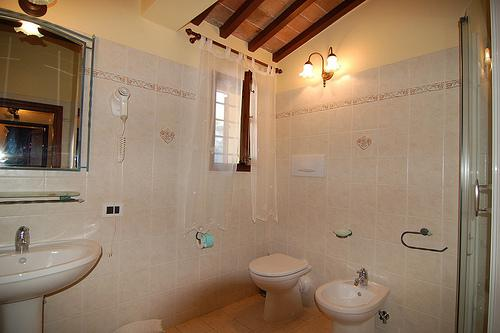Question: how is water obtained from sink?
Choices:
A. Cups.
B. Faucets.
C. Glasses.
D. Bottles.
Answer with the letter. Answer: B Question: what is on left wall above roll of toilet paper?
Choices:
A. Towel rack.
B. Built in shelf.
C. Window.
D. Picture.
Answer with the letter. Answer: C Question: where was this photo taken?
Choices:
A. Bathroom.
B. Living room.
C. Bedroom.
D. Kitchen.
Answer with the letter. Answer: A Question: what is on the wall to left of commode?
Choices:
A. Bathtub.
B. Shower.
C. Toilet paper.
D. Sink.
Answer with the letter. Answer: C Question: why is toilet paper positioned where it is?
Choices:
A. To be out of the way.
B. Only spot available.
C. For easy access.
D. Made a mistake when mounting holder.
Answer with the letter. Answer: C 